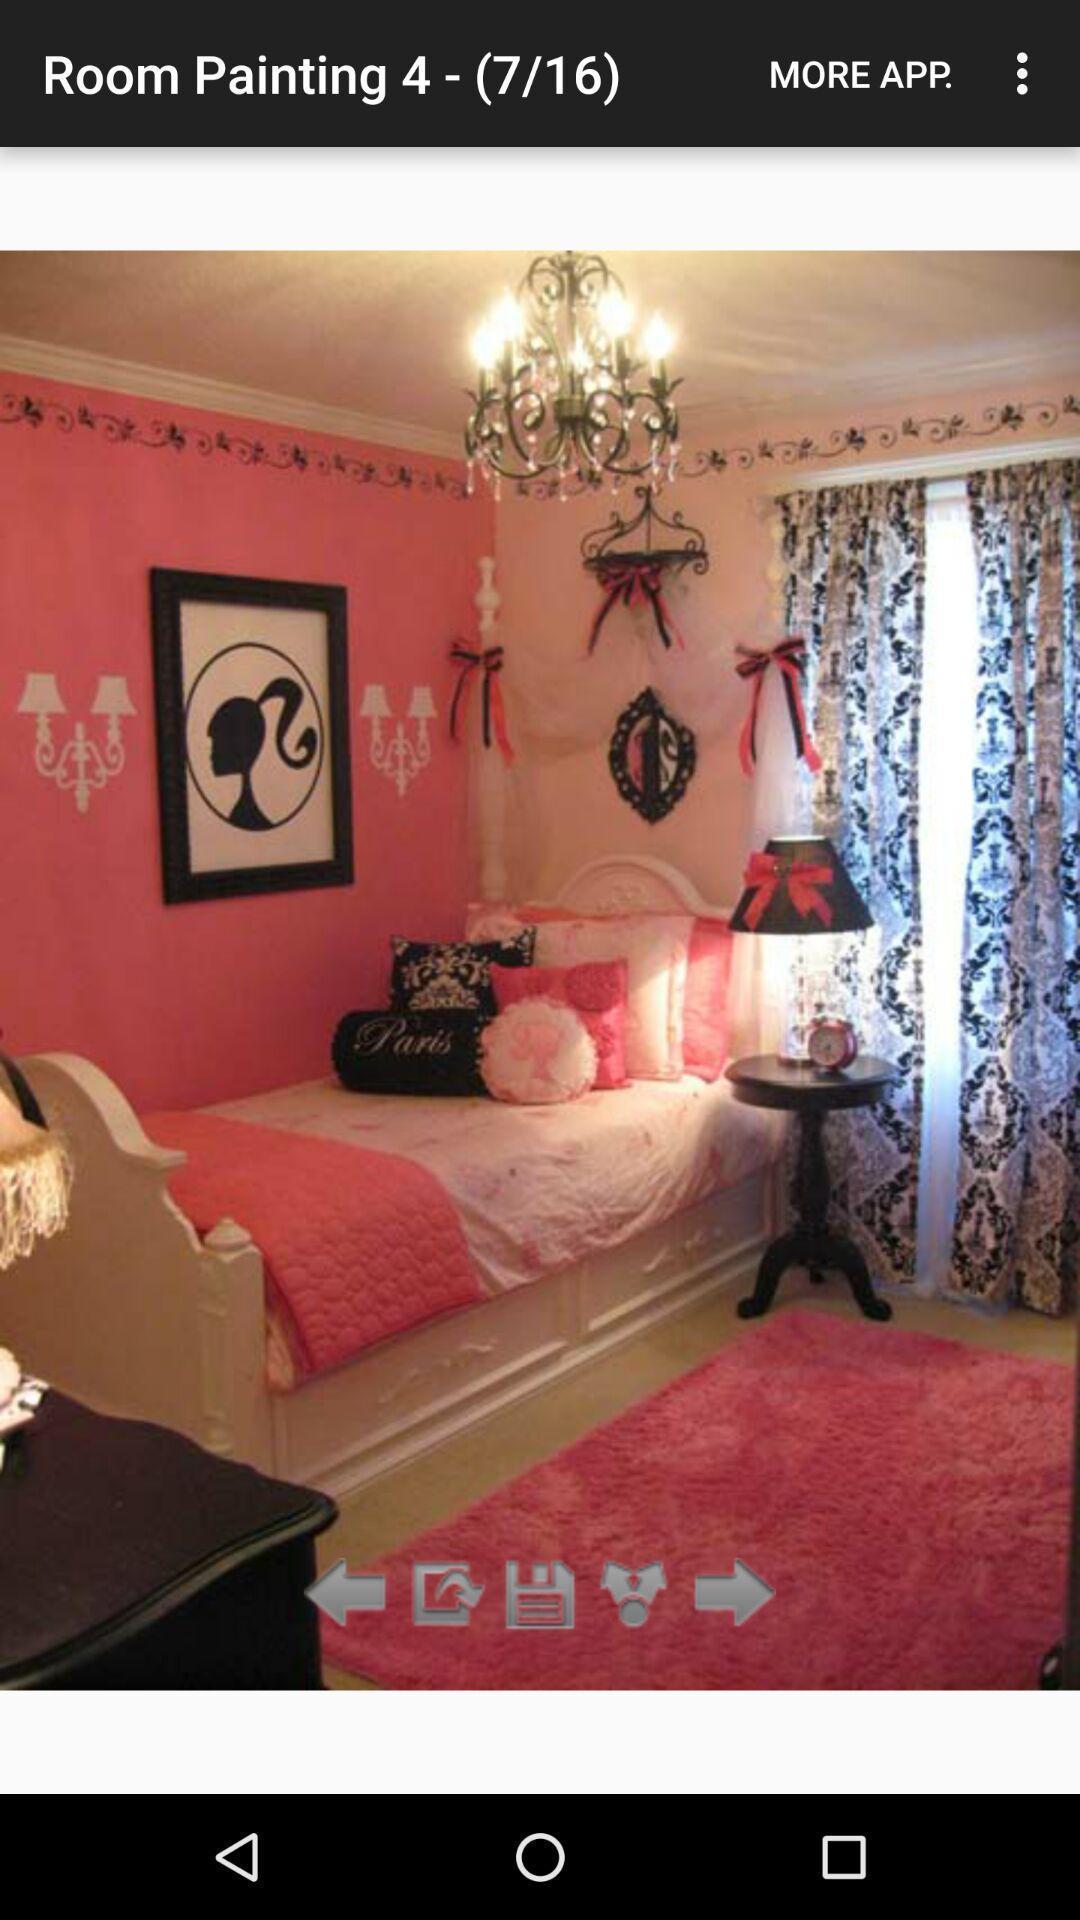What is the overall content of this screenshot? Page showing image of a bedroom. 